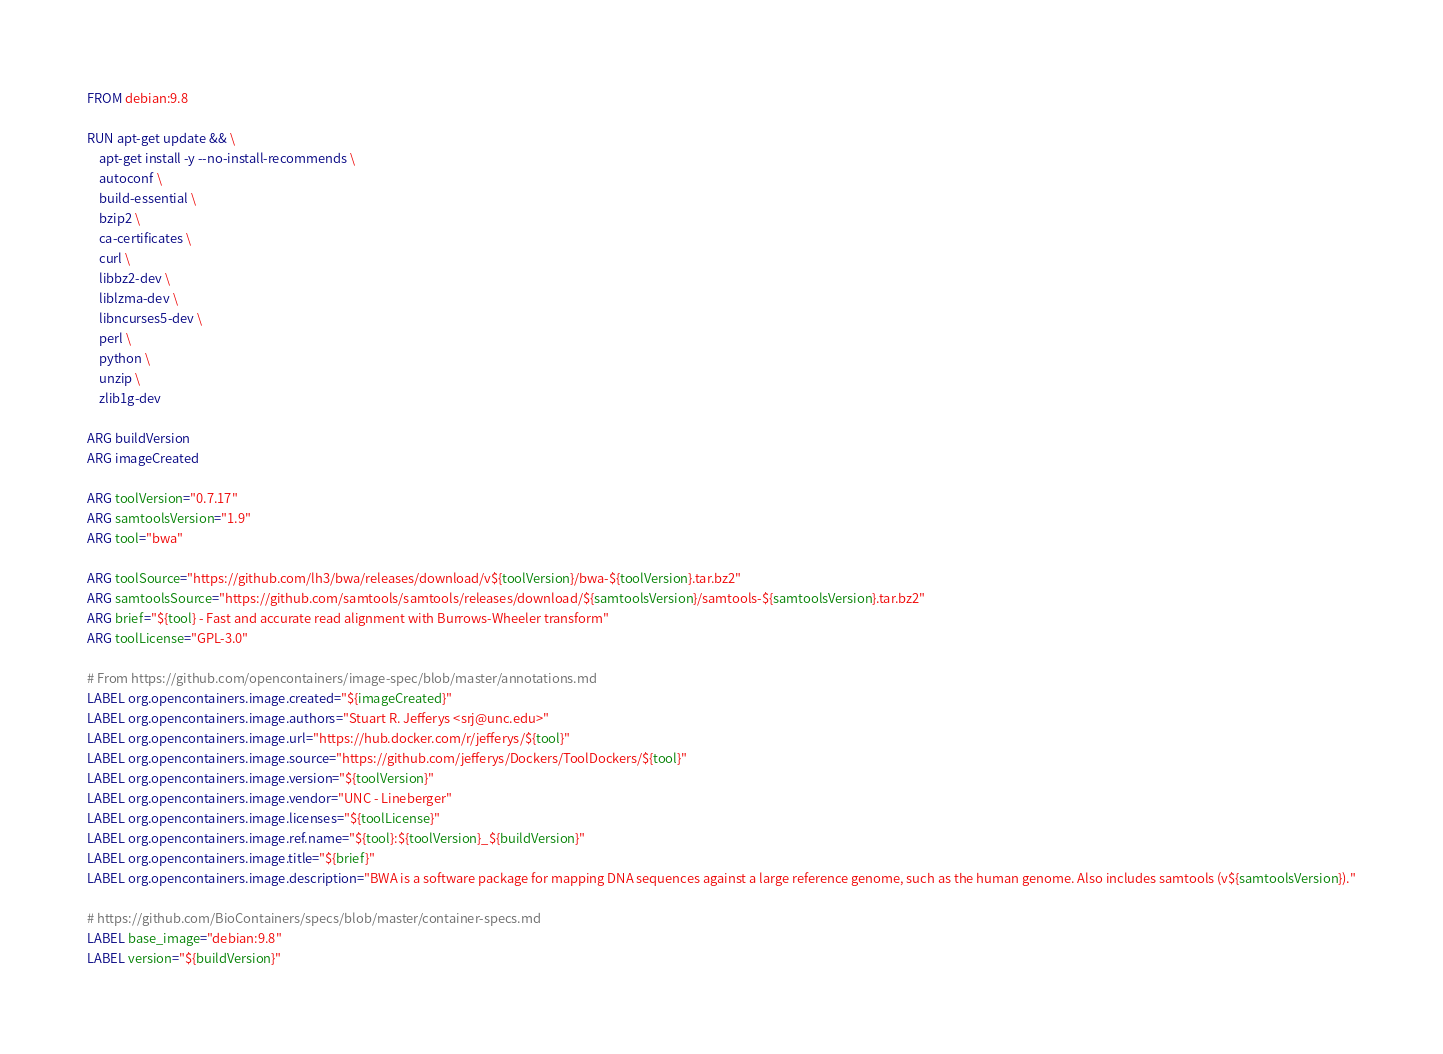<code> <loc_0><loc_0><loc_500><loc_500><_Dockerfile_>FROM debian:9.8

RUN apt-get update && \
    apt-get install -y --no-install-recommends \
    autoconf \
    build-essential \
    bzip2 \
    ca-certificates \
    curl \
    libbz2-dev \
    liblzma-dev \
    libncurses5-dev \
    perl \
    python \
    unzip \
    zlib1g-dev

ARG buildVersion
ARG imageCreated

ARG toolVersion="0.7.17"
ARG samtoolsVersion="1.9"
ARG tool="bwa"

ARG toolSource="https://github.com/lh3/bwa/releases/download/v${toolVersion}/bwa-${toolVersion}.tar.bz2"
ARG samtoolsSource="https://github.com/samtools/samtools/releases/download/${samtoolsVersion}/samtools-${samtoolsVersion}.tar.bz2"
ARG brief="${tool} - Fast and accurate read alignment with Burrows-Wheeler transform"
ARG toolLicense="GPL-3.0"

# From https://github.com/opencontainers/image-spec/blob/master/annotations.md
LABEL org.opencontainers.image.created="${imageCreated}"
LABEL org.opencontainers.image.authors="Stuart R. Jefferys <srj@unc.edu>"
LABEL org.opencontainers.image.url="https://hub.docker.com/r/jefferys/${tool}"
LABEL org.opencontainers.image.source="https://github.com/jefferys/Dockers/ToolDockers/${tool}"
LABEL org.opencontainers.image.version="${toolVersion}"
LABEL org.opencontainers.image.vendor="UNC - Lineberger"
LABEL org.opencontainers.image.licenses="${toolLicense}"
LABEL org.opencontainers.image.ref.name="${tool}:${toolVersion}_${buildVersion}"
LABEL org.opencontainers.image.title="${brief}"
LABEL org.opencontainers.image.description="BWA is a software package for mapping DNA sequences against a large reference genome, such as the human genome. Also includes samtools (v${samtoolsVersion})."

# https://github.com/BioContainers/specs/blob/master/container-specs.md
LABEL base_image="debian:9.8"
LABEL version="${buildVersion}"</code> 